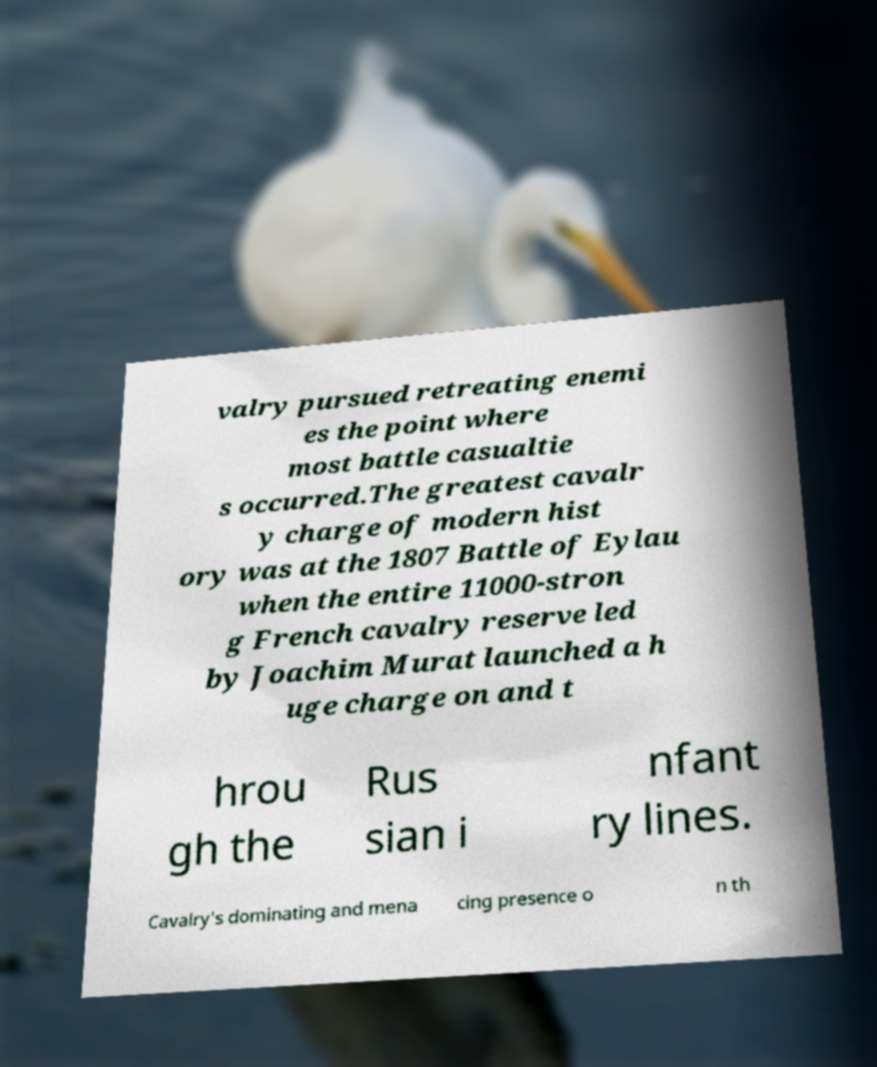I need the written content from this picture converted into text. Can you do that? valry pursued retreating enemi es the point where most battle casualtie s occurred.The greatest cavalr y charge of modern hist ory was at the 1807 Battle of Eylau when the entire 11000-stron g French cavalry reserve led by Joachim Murat launched a h uge charge on and t hrou gh the Rus sian i nfant ry lines. Cavalry's dominating and mena cing presence o n th 